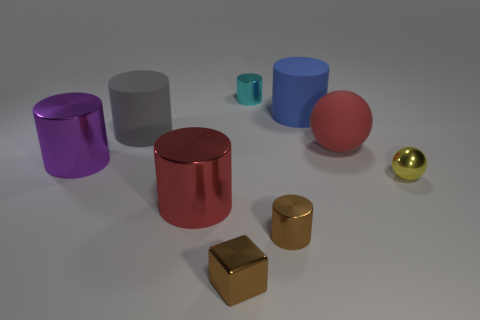What is the material of the large red thing on the right side of the red thing left of the tiny brown cylinder?
Give a very brief answer. Rubber. Are there any tiny brown objects of the same shape as the big purple metal object?
Keep it short and to the point. Yes. The tiny yellow metallic thing is what shape?
Your answer should be very brief. Sphere. What is the material of the big blue thing behind the rubber thing that is on the left side of the red object in front of the yellow sphere?
Make the answer very short. Rubber. Is the number of yellow things left of the large blue cylinder greater than the number of tiny purple cylinders?
Provide a succinct answer. No. There is a gray cylinder that is the same size as the blue matte cylinder; what material is it?
Offer a terse response. Rubber. Are there any brown metallic objects that have the same size as the red rubber ball?
Your response must be concise. No. What size is the brown shiny thing right of the cyan metallic cylinder?
Your answer should be compact. Small. How big is the red rubber sphere?
Make the answer very short. Large. What number of balls are big red objects or big brown rubber objects?
Provide a succinct answer. 1. 